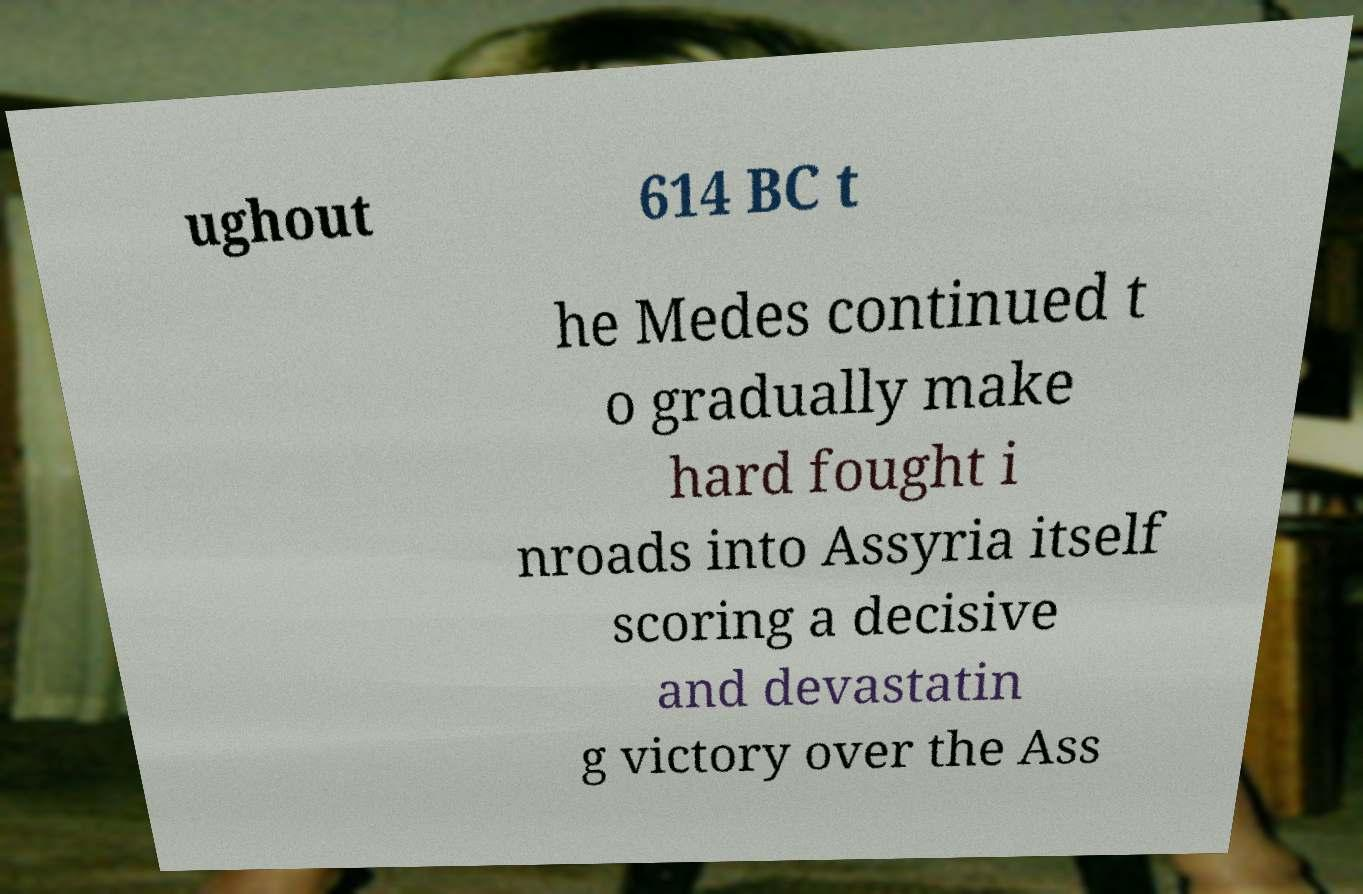There's text embedded in this image that I need extracted. Can you transcribe it verbatim? ughout 614 BC t he Medes continued t o gradually make hard fought i nroads into Assyria itself scoring a decisive and devastatin g victory over the Ass 